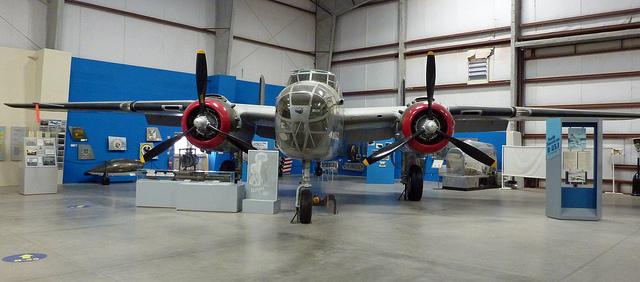Is this a modern plane?
Concise answer only. No. How many propellers on the plane?
Quick response, please. 2. What is this?
Write a very short answer. Plane. 